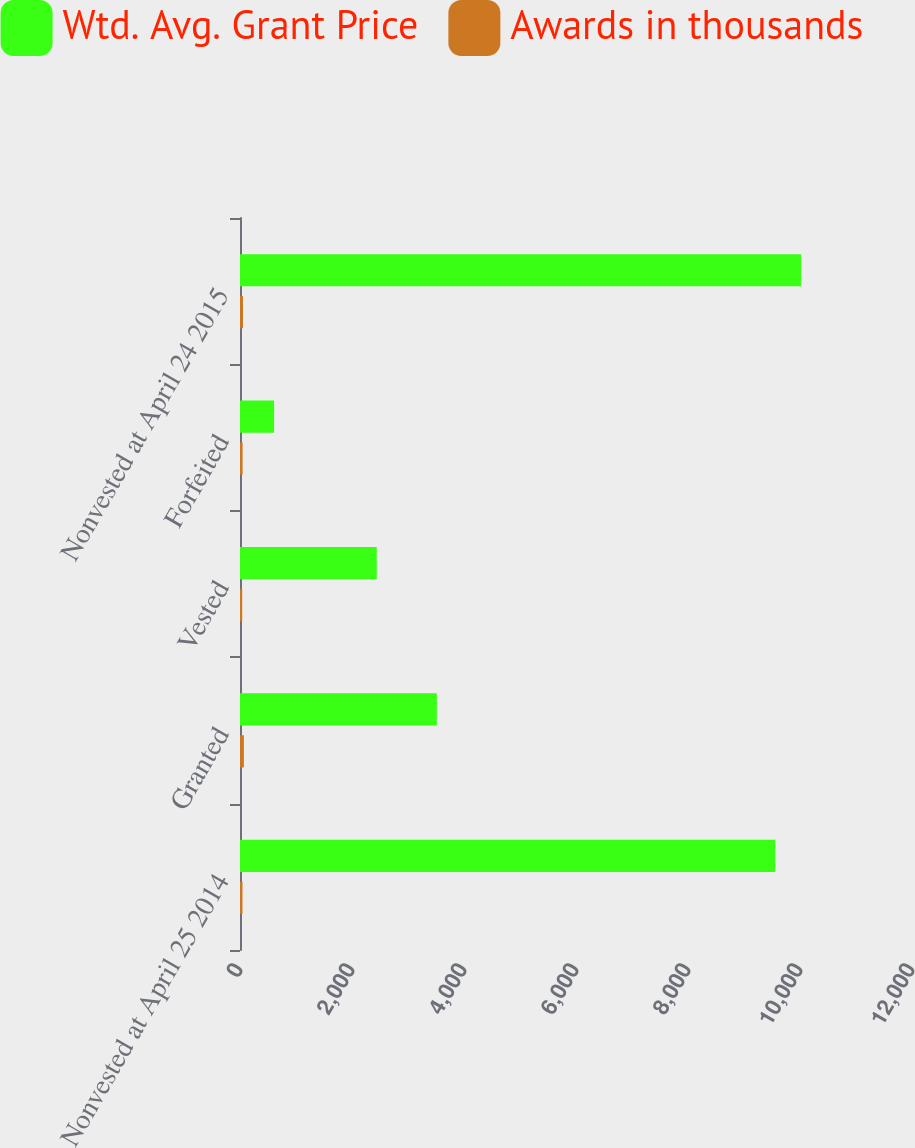Convert chart to OTSL. <chart><loc_0><loc_0><loc_500><loc_500><stacked_bar_chart><ecel><fcel>Nonvested at April 25 2014<fcel>Granted<fcel>Vested<fcel>Forfeited<fcel>Nonvested at April 24 2015<nl><fcel>Wtd. Avg. Grant Price<fcel>9558<fcel>3515<fcel>2442<fcel>609<fcel>10022<nl><fcel>Awards in thousands<fcel>44.06<fcel>69.3<fcel>39.53<fcel>46.22<fcel>53.88<nl></chart> 